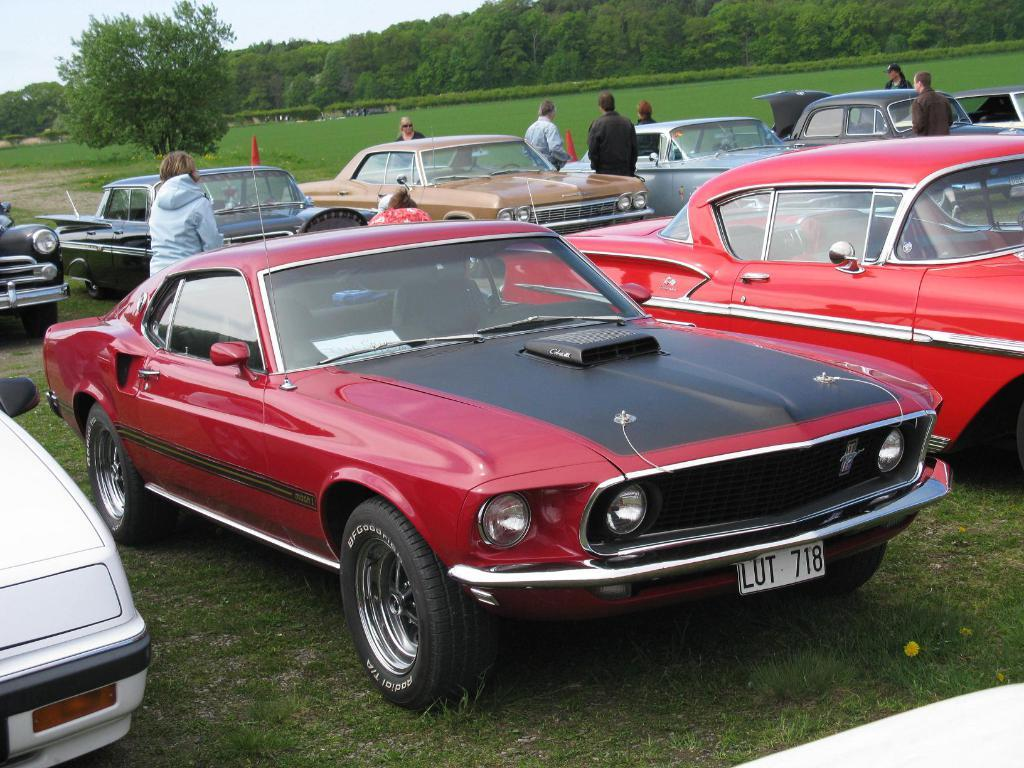Who or what is present in the image? There are people and vehicles in the image. What can be seen beneath the people and vehicles? The ground is visible in the image. What is visible in the background of the image? There are trees and the sky in the background of the image. What type of toys can be seen being controlled by the kitten in the image? There is no kitten or toys present in the image. 